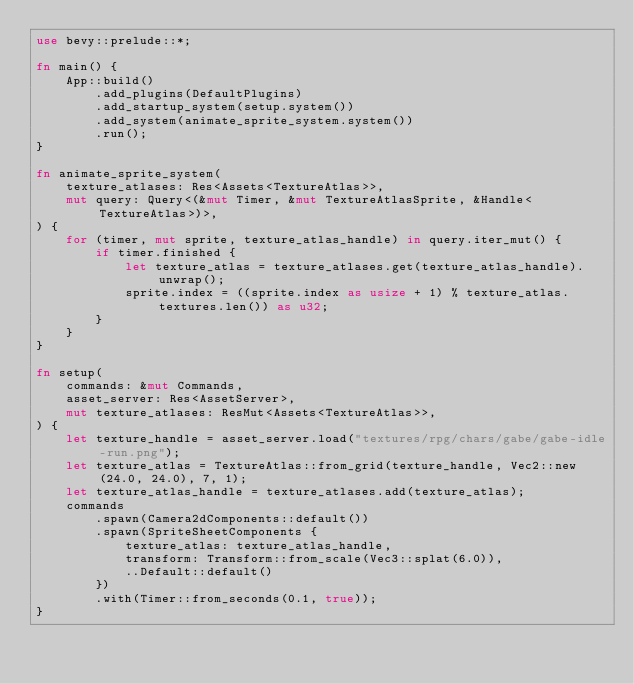Convert code to text. <code><loc_0><loc_0><loc_500><loc_500><_Rust_>use bevy::prelude::*;

fn main() {
    App::build()
        .add_plugins(DefaultPlugins)
        .add_startup_system(setup.system())
        .add_system(animate_sprite_system.system())
        .run();
}

fn animate_sprite_system(
    texture_atlases: Res<Assets<TextureAtlas>>,
    mut query: Query<(&mut Timer, &mut TextureAtlasSprite, &Handle<TextureAtlas>)>,
) {
    for (timer, mut sprite, texture_atlas_handle) in query.iter_mut() {
        if timer.finished {
            let texture_atlas = texture_atlases.get(texture_atlas_handle).unwrap();
            sprite.index = ((sprite.index as usize + 1) % texture_atlas.textures.len()) as u32;
        }
    }
}

fn setup(
    commands: &mut Commands,
    asset_server: Res<AssetServer>,
    mut texture_atlases: ResMut<Assets<TextureAtlas>>,
) {
    let texture_handle = asset_server.load("textures/rpg/chars/gabe/gabe-idle-run.png");
    let texture_atlas = TextureAtlas::from_grid(texture_handle, Vec2::new(24.0, 24.0), 7, 1);
    let texture_atlas_handle = texture_atlases.add(texture_atlas);
    commands
        .spawn(Camera2dComponents::default())
        .spawn(SpriteSheetComponents {
            texture_atlas: texture_atlas_handle,
            transform: Transform::from_scale(Vec3::splat(6.0)),
            ..Default::default()
        })
        .with(Timer::from_seconds(0.1, true));
}
</code> 